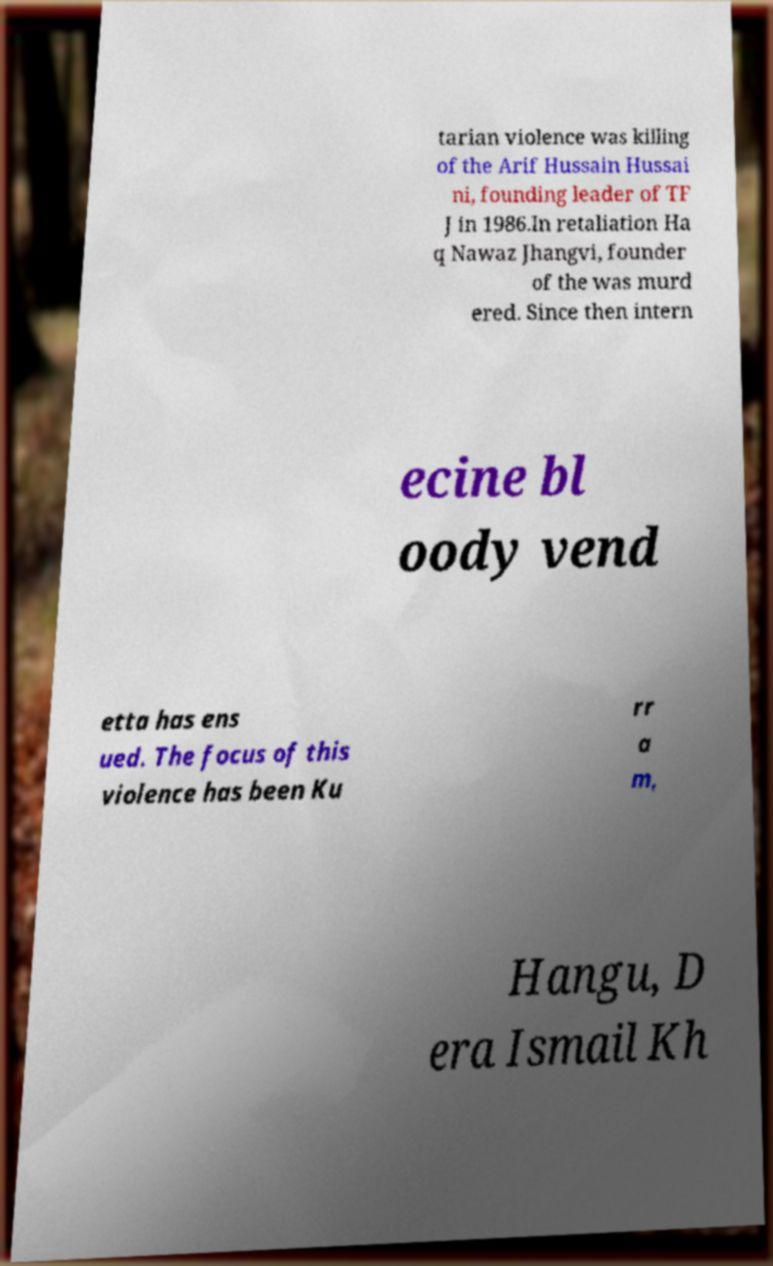For documentation purposes, I need the text within this image transcribed. Could you provide that? tarian violence was killing of the Arif Hussain Hussai ni, founding leader of TF J in 1986.In retaliation Ha q Nawaz Jhangvi, founder of the was murd ered. Since then intern ecine bl oody vend etta has ens ued. The focus of this violence has been Ku rr a m, Hangu, D era Ismail Kh 